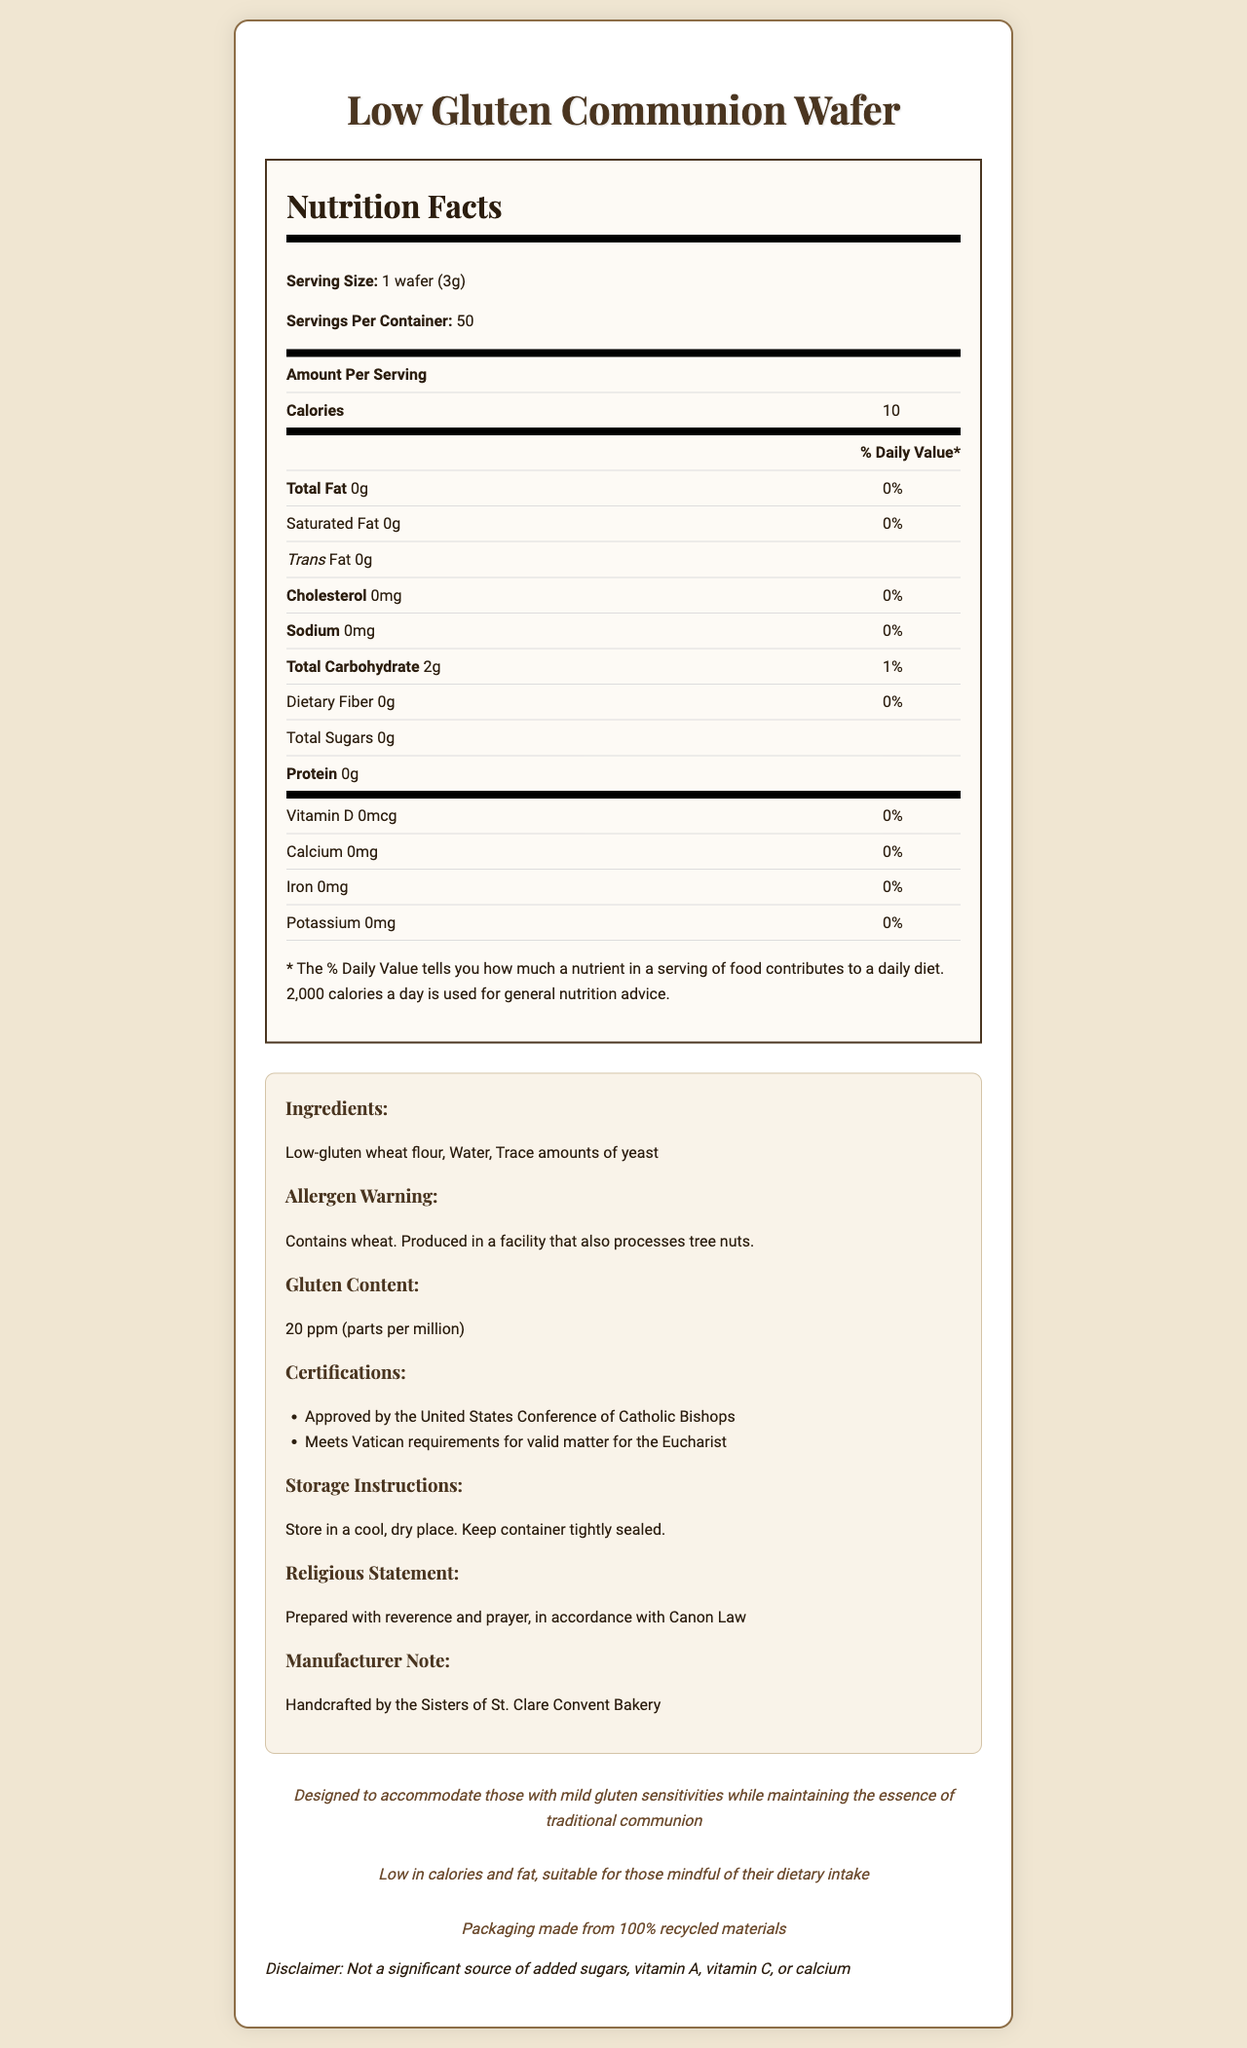What is the serving size of the low gluten communion wafer? The serving size is mentioned at the beginning of the Nutrition Facts section as "Serving Size: 1 wafer (3g)".
Answer: 1 wafer (3g) How many calories are in one serving of the wafer? The number of calories per serving is listed in the Nutrition Facts section next to "Calories".
Answer: 10 What ingredients are used in the low gluten communion wafer? The list of ingredients is found in the additional information section under the subheading "Ingredients".
Answer: Low-gluten wheat flour, Water, Trace amounts of yeast What is the gluten content of the wafer? The gluten content is specified in the additional information section under the subheading "Gluten Content".
Answer: 20 ppm (parts per million) Does the wafer contain any added sugars? The Nutrition Facts section shows that "Total Sugars" is 0g.
Answer: No What allergens are present in the wafer? The allergen information is stated under the subheading "Allergen Warning" in the additional information section.
Answer: Contains wheat. Produced in a facility that also processes tree nuts. Who approves the low gluten communion wafer usage for the Eucharist? A. FDA B. USDA C. United States Conference of Catholic Bishops D. Vatican One of the certifications listed is "Approved by the United States Conference of Catholic Bishops".
Answer: C. United States Conference of Catholic Bishops What is the recommended storage condition for the wafers? A. Refrigerated B. Cool, dry place C. Warm, humid place D. Frozen The storage instructions state "Store in a cool, dry place".
Answer: B. Cool, dry place Is the wafer suitable for someone monitoring their fat intake? The wafer has 0g total fat per serving as stated in the Nutrition Facts section, and the additional information mentions it is "low in calories and fat".
Answer: Yes Can people with severe gluten allergies consume this wafer? The wafer is low gluten with 20 ppm gluten content, which may not be suitable for those with severe gluten allergies.
Answer: Not recommended Explain the entire document The Nutrition Facts Label provides detailed nutritional information and additional context about the product to cater to specific dietary restrictions and religious practices.
Answer: The document is a comprehensive Nutrition Facts Label for a homemade low gluten communion wafer. It includes nutritional information such as serving size, calories, and macronutrient content. There are additional details about ingredients, allergens, certifications, storage instructions, and special notes for religious and dietary considerations. The wafer is designed to be low in calories and fat while maintaining the traditional essence of communion wafers and has a low gluten content of 20 ppm. Who manufactures the low gluten communion wafers? The manufacturer is mentioned in the additional information under the subheading "Manufacturer Note".
Answer: Sisters of St. Clare Convent Bakery When were the wafers produced? The document does not provide any information about the production date of the wafers.
Answer: Cannot be determined Are the packaging materials environmentally friendly? The additional information includes a statement "Packaging made from 100% recycled materials" under "Sustainability Note".
Answer: Yes 